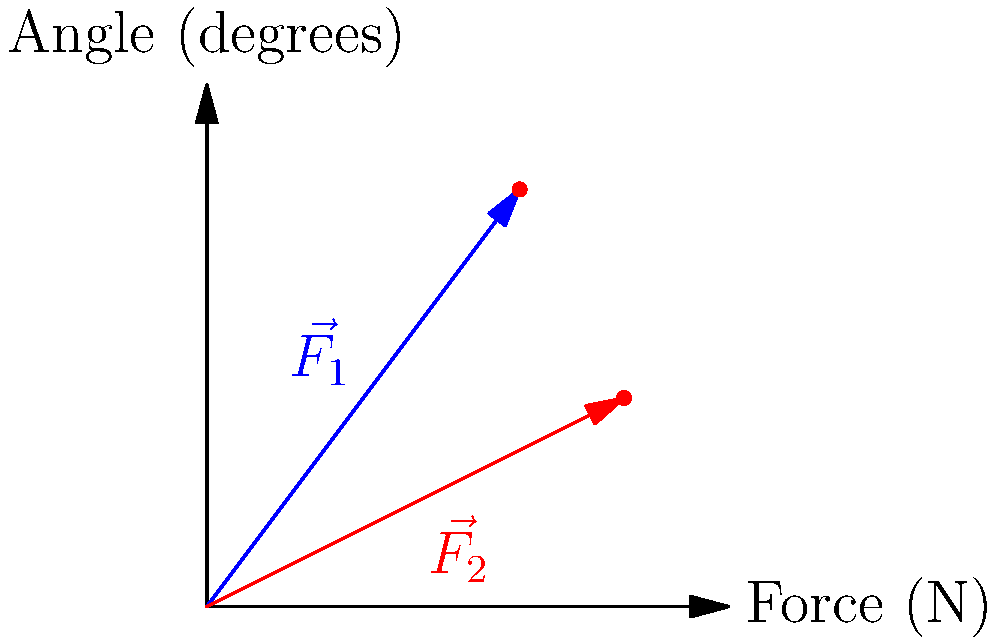As a nurse, you need to safely transfer a patient from their bed to a wheelchair. Two force vectors, $\vec{F_1}$ and $\vec{F_2}$, are applied during the transfer. $\vec{F_1}$ has a magnitude of 5 N at an angle of 53.13° from the horizontal, while $\vec{F_2}$ has a magnitude of 4.47 N at an angle of 26.57°. What is the magnitude of the resultant force vector? To find the magnitude of the resultant force vector, we need to follow these steps:

1. Decompose each force vector into its x and y components:
   For $\vec{F_1}$: 
   $F_{1x} = 5 \cos(53.13°) = 3$ N
   $F_{1y} = 5 \sin(53.13°) = 4$ N

   For $\vec{F_2}$:
   $F_{2x} = 4.47 \cos(26.57°) = 4$ N
   $F_{2y} = 4.47 \sin(26.57°) = 2$ N

2. Sum the x and y components:
   $F_x = F_{1x} + F_{2x} = 3 + 4 = 7$ N
   $F_y = F_{1y} + F_{2y} = 4 + 2 = 6$ N

3. Calculate the magnitude of the resultant force using the Pythagorean theorem:
   $|\vec{F_R}| = \sqrt{F_x^2 + F_y^2} = \sqrt{7^2 + 6^2} = \sqrt{49 + 36} = \sqrt{85} \approx 9.22$ N

Therefore, the magnitude of the resultant force vector is approximately 9.22 N.
Answer: 9.22 N 